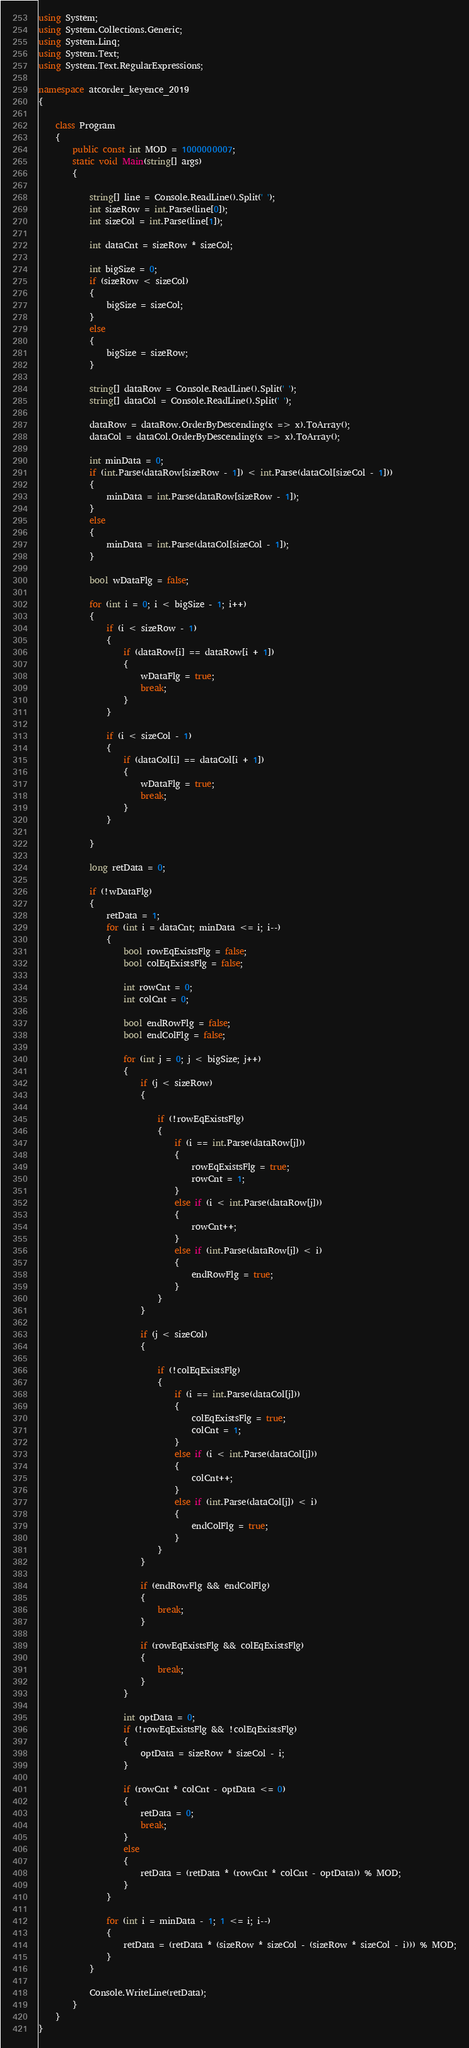<code> <loc_0><loc_0><loc_500><loc_500><_C#_>using System;
using System.Collections.Generic;
using System.Linq;
using System.Text;
using System.Text.RegularExpressions;

namespace atcorder_keyence_2019
{

    class Program
    {
        public const int MOD = 1000000007;
        static void Main(string[] args)
        {

            string[] line = Console.ReadLine().Split(' ');
            int sizeRow = int.Parse(line[0]);
            int sizeCol = int.Parse(line[1]);

            int dataCnt = sizeRow * sizeCol;

            int bigSize = 0;
            if (sizeRow < sizeCol)
            {
                bigSize = sizeCol;
            }
            else
            {
                bigSize = sizeRow;
            }

            string[] dataRow = Console.ReadLine().Split(' ');
            string[] dataCol = Console.ReadLine().Split(' ');

            dataRow = dataRow.OrderByDescending(x => x).ToArray();
            dataCol = dataCol.OrderByDescending(x => x).ToArray();

            int minData = 0;
            if (int.Parse(dataRow[sizeRow - 1]) < int.Parse(dataCol[sizeCol - 1]))
            {
                minData = int.Parse(dataRow[sizeRow - 1]);
            }
            else
            {
                minData = int.Parse(dataCol[sizeCol - 1]);            
            }

            bool wDataFlg = false;

            for (int i = 0; i < bigSize - 1; i++)
            {
                if (i < sizeRow - 1)
                {
                    if (dataRow[i] == dataRow[i + 1])
                    {
                        wDataFlg = true;
                        break;
                    }
                }

                if (i < sizeCol - 1)
                {
                    if (dataCol[i] == dataCol[i + 1])
                    {
                        wDataFlg = true;
                        break;
                    }
                }

            }

            long retData = 0;

            if (!wDataFlg)
            {
                retData = 1;
                for (int i = dataCnt; minData <= i; i--)
                {
                    bool rowEqExistsFlg = false;
                    bool colEqExistsFlg = false;

                    int rowCnt = 0;
                    int colCnt = 0;

                    bool endRowFlg = false;
                    bool endColFlg = false;

                    for (int j = 0; j < bigSize; j++)
                    {
                        if (j < sizeRow)
                        {

                            if (!rowEqExistsFlg)
                            {
                                if (i == int.Parse(dataRow[j]))
                                {
                                    rowEqExistsFlg = true;
                                    rowCnt = 1;
                                }
                                else if (i < int.Parse(dataRow[j]))
                                {
                                    rowCnt++;
                                }
                                else if (int.Parse(dataRow[j]) < i)
                                {
                                    endRowFlg = true;
                                }
                            }
                        }

                        if (j < sizeCol)
                        {

                            if (!colEqExistsFlg)
                            {
                                if (i == int.Parse(dataCol[j]))
                                {
                                    colEqExistsFlg = true;
                                    colCnt = 1;
                                }
                                else if (i < int.Parse(dataCol[j]))
                                {
                                    colCnt++;
                                }
                                else if (int.Parse(dataCol[j]) < i)
                                {
                                    endColFlg = true;
                                }
                            }
                        }

                        if (endRowFlg && endColFlg)
                        {
                            break;
                        }

                        if (rowEqExistsFlg && colEqExistsFlg)
                        {
                            break;
                        }
                    }

                    int optData = 0;
                    if (!rowEqExistsFlg && !colEqExistsFlg)
                    {
                        optData = sizeRow * sizeCol - i;
                    }

                    if (rowCnt * colCnt - optData <= 0)
                    {
                        retData = 0;
                        break;
                    }
                    else
                    {
                        retData = (retData * (rowCnt * colCnt - optData)) % MOD;
                    }
                }

                for (int i = minData - 1; 1 <= i; i--)
                {
                    retData = (retData * (sizeRow * sizeCol - (sizeRow * sizeCol - i))) % MOD;
                }
            }

            Console.WriteLine(retData);
        }
    }
}</code> 